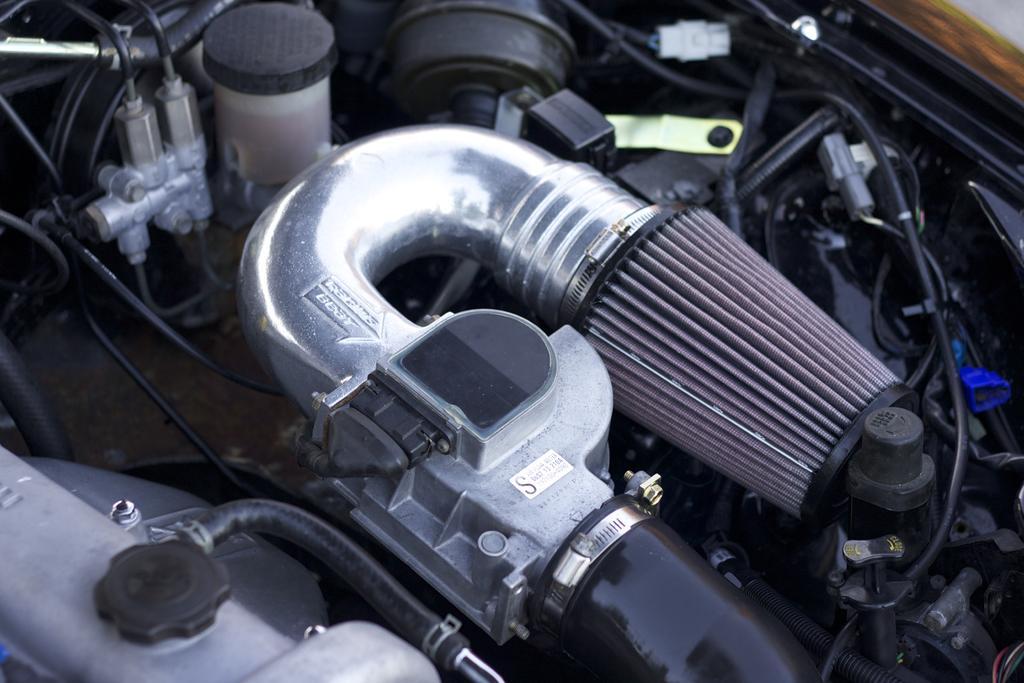Can you describe this image briefly? It seems like an engine of a vehicle. 